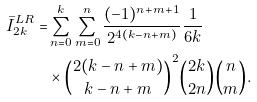<formula> <loc_0><loc_0><loc_500><loc_500>\bar { I } _ { 2 k } ^ { L R } = & \sum _ { n = 0 } ^ { k } \sum _ { m = 0 } ^ { n } \frac { ( - 1 ) ^ { n + m + 1 } } { 2 ^ { 4 ( k - n + m ) } } \frac { 1 } { 6 k } \\ & \times \binom { 2 ( k - n + m ) } { k - n + m } ^ { 2 } \binom { 2 k } { 2 n } \binom { n } { m } .</formula> 